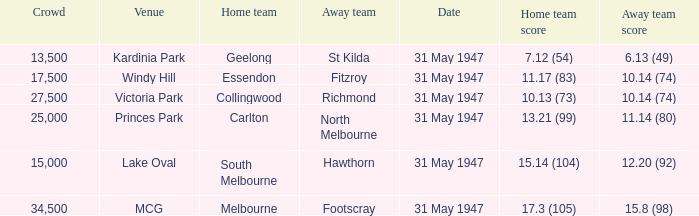What day is south melbourne at home? 31 May 1947. 